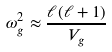Convert formula to latex. <formula><loc_0><loc_0><loc_500><loc_500>\omega _ { g } ^ { 2 } \approx \frac { \ell ( \ell + 1 ) } { V _ { g } }</formula> 